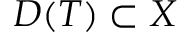Convert formula to latex. <formula><loc_0><loc_0><loc_500><loc_500>D ( T ) \subset X</formula> 